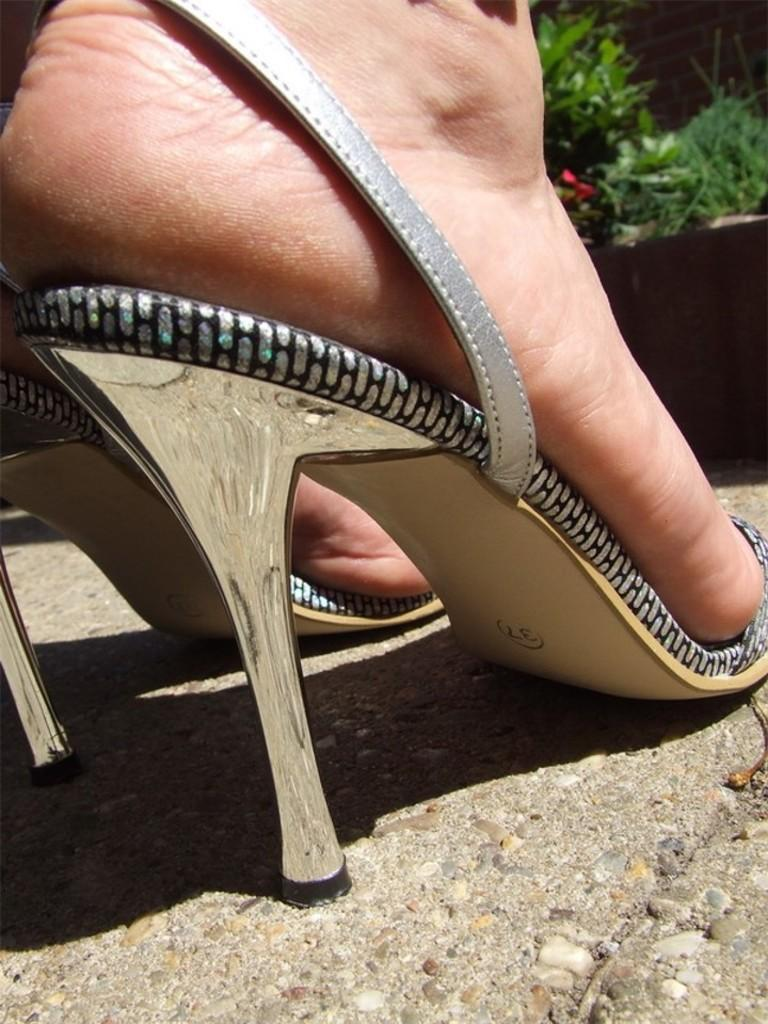Who is present in the image? There is a lady in the image. What type of footwear is the lady wearing? The lady is wearing heels. What type of birds can be seen flying around the lady in the image? There are no birds visible in the image. Is the lady wearing a scarf in the image? The provided facts do not mention a scarf, so we cannot determine if the lady is wearing one. 